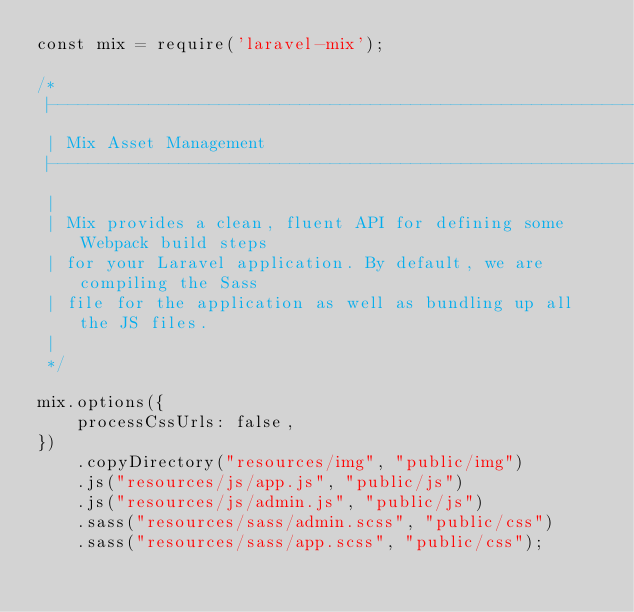<code> <loc_0><loc_0><loc_500><loc_500><_JavaScript_>const mix = require('laravel-mix');

/*
 |--------------------------------------------------------------------------
 | Mix Asset Management
 |--------------------------------------------------------------------------
 |
 | Mix provides a clean, fluent API for defining some Webpack build steps
 | for your Laravel application. By default, we are compiling the Sass
 | file for the application as well as bundling up all the JS files.
 |
 */

mix.options({
    processCssUrls: false,
})
    .copyDirectory("resources/img", "public/img")
    .js("resources/js/app.js", "public/js")
    .js("resources/js/admin.js", "public/js")
    .sass("resources/sass/admin.scss", "public/css")
    .sass("resources/sass/app.scss", "public/css");</code> 